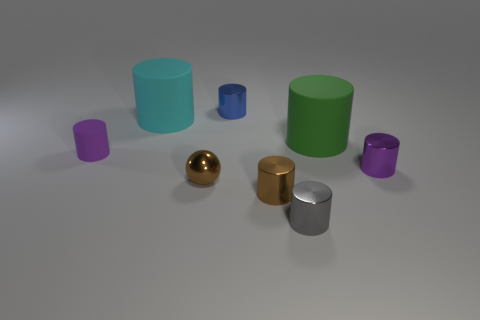Are there an equal number of large green matte cylinders in front of the tiny brown metal cylinder and brown shiny things? After examining the image, it appears that there are, in fact, two large green matte cylinders, one positioned in front of the tiny brown metal cylinder and the other slightly to the right. The 'brown shiny things' you referred to likely denote the brown shiny cylinder and the golden shiny sphere, which total two as well. Therefore, the number of large green matte cylinders and the referenced brown objects are equal. 